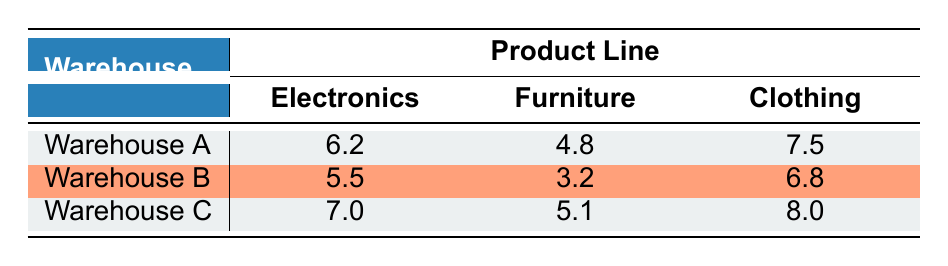What is the inventory turnover rate for Clothing in Warehouse A? According to the table, the inventory turnover rate specifically for Clothing in Warehouse A is listed directly as 7.5.
Answer: 7.5 Which warehouse has the highest inventory turnover rate for Electronics? From the table, Warehouse C has the highest inventory turnover rate for Electronics, which is noted as 7.0.
Answer: 7.0 What is the average inventory turnover rate for Furniture across all warehouses? The rates for Furniture across the warehouses are 4.8 (Warehouse A), 3.2 (Warehouse B), and 5.1 (Warehouse C). The sum of these values is 4.8 + 3.2 + 5.1 = 13.1, and dividing by 3 gives an average of 13.1/3 = approximately 4.37.
Answer: 4.37 Is the inventory turnover rate for Electronics in Warehouse B greater than that in Warehouse A? The inventory turnover rate for Electronics in Warehouse B is 5.5, while in Warehouse A, it is 6.2. Since 5.5 is less than 6.2, the statement is false.
Answer: No Which product line has the lowest inventory turnover rate in the entire table? By comparing all the values, the Furniture inventory turnover rate in Warehouse B is the lowest at 3.2.
Answer: 3.2 What is the difference in inventory turnover rates for Clothing between Warehouse C and Warehouse A? The Clothing turnover rate in Warehouse C is 8.0 and in Warehouse A is 7.5. The difference is calculated as 8.0 - 7.5 = 0.5.
Answer: 0.5 Does Warehouse B have an inventory turnover rate for Clothing that exceeds 7.0? The Clothing turnover rate in Warehouse B is 6.8, which is less than 7.0. Hence, the statement is false.
Answer: No How does the Furniture inventory turnover rate in Warehouse C compare to that in Warehouse A? The rate for Furniture in Warehouse C is 5.1, while in Warehouse A it is 4.8. Since 5.1 is greater than 4.8, Warehouse C has a higher rate for Furniture.
Answer: Yes 